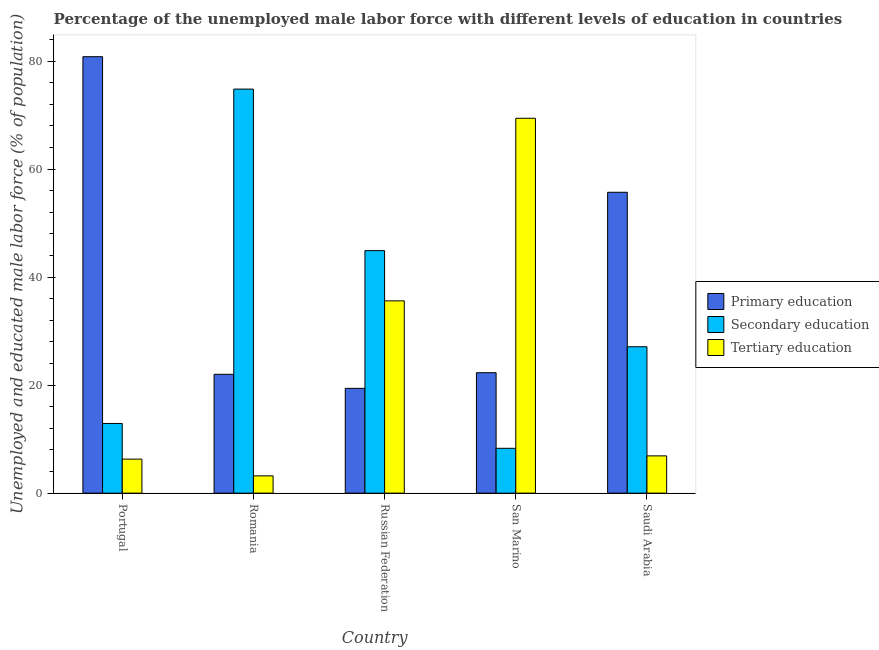How many different coloured bars are there?
Make the answer very short. 3. How many bars are there on the 1st tick from the left?
Give a very brief answer. 3. What is the label of the 5th group of bars from the left?
Your response must be concise. Saudi Arabia. What is the percentage of male labor force who received tertiary education in Portugal?
Provide a short and direct response. 6.3. Across all countries, what is the maximum percentage of male labor force who received tertiary education?
Your answer should be very brief. 69.4. Across all countries, what is the minimum percentage of male labor force who received secondary education?
Make the answer very short. 8.3. In which country was the percentage of male labor force who received primary education minimum?
Offer a terse response. Russian Federation. What is the total percentage of male labor force who received primary education in the graph?
Provide a succinct answer. 200.2. What is the difference between the percentage of male labor force who received tertiary education in Russian Federation and that in San Marino?
Give a very brief answer. -33.8. What is the difference between the percentage of male labor force who received tertiary education in Russian Federation and the percentage of male labor force who received primary education in San Marino?
Provide a short and direct response. 13.3. What is the average percentage of male labor force who received tertiary education per country?
Offer a very short reply. 24.28. What is the difference between the percentage of male labor force who received tertiary education and percentage of male labor force who received primary education in Portugal?
Provide a short and direct response. -74.5. In how many countries, is the percentage of male labor force who received tertiary education greater than 8 %?
Offer a terse response. 2. What is the ratio of the percentage of male labor force who received tertiary education in Russian Federation to that in San Marino?
Provide a succinct answer. 0.51. What is the difference between the highest and the second highest percentage of male labor force who received tertiary education?
Your answer should be very brief. 33.8. What is the difference between the highest and the lowest percentage of male labor force who received primary education?
Keep it short and to the point. 61.4. Is the sum of the percentage of male labor force who received tertiary education in Portugal and Saudi Arabia greater than the maximum percentage of male labor force who received secondary education across all countries?
Your answer should be compact. No. What does the 2nd bar from the left in Portugal represents?
Ensure brevity in your answer.  Secondary education. What does the 1st bar from the right in Russian Federation represents?
Ensure brevity in your answer.  Tertiary education. How many bars are there?
Your response must be concise. 15. How are the legend labels stacked?
Provide a short and direct response. Vertical. What is the title of the graph?
Provide a succinct answer. Percentage of the unemployed male labor force with different levels of education in countries. What is the label or title of the Y-axis?
Offer a very short reply. Unemployed and educated male labor force (% of population). What is the Unemployed and educated male labor force (% of population) of Primary education in Portugal?
Ensure brevity in your answer.  80.8. What is the Unemployed and educated male labor force (% of population) in Secondary education in Portugal?
Your response must be concise. 12.9. What is the Unemployed and educated male labor force (% of population) of Tertiary education in Portugal?
Ensure brevity in your answer.  6.3. What is the Unemployed and educated male labor force (% of population) of Secondary education in Romania?
Provide a succinct answer. 74.8. What is the Unemployed and educated male labor force (% of population) in Tertiary education in Romania?
Your answer should be compact. 3.2. What is the Unemployed and educated male labor force (% of population) in Primary education in Russian Federation?
Make the answer very short. 19.4. What is the Unemployed and educated male labor force (% of population) of Secondary education in Russian Federation?
Keep it short and to the point. 44.9. What is the Unemployed and educated male labor force (% of population) of Tertiary education in Russian Federation?
Ensure brevity in your answer.  35.6. What is the Unemployed and educated male labor force (% of population) in Primary education in San Marino?
Your answer should be very brief. 22.3. What is the Unemployed and educated male labor force (% of population) of Secondary education in San Marino?
Provide a succinct answer. 8.3. What is the Unemployed and educated male labor force (% of population) in Tertiary education in San Marino?
Give a very brief answer. 69.4. What is the Unemployed and educated male labor force (% of population) in Primary education in Saudi Arabia?
Your answer should be compact. 55.7. What is the Unemployed and educated male labor force (% of population) in Secondary education in Saudi Arabia?
Your answer should be compact. 27.1. What is the Unemployed and educated male labor force (% of population) of Tertiary education in Saudi Arabia?
Make the answer very short. 6.9. Across all countries, what is the maximum Unemployed and educated male labor force (% of population) in Primary education?
Your answer should be very brief. 80.8. Across all countries, what is the maximum Unemployed and educated male labor force (% of population) in Secondary education?
Provide a short and direct response. 74.8. Across all countries, what is the maximum Unemployed and educated male labor force (% of population) of Tertiary education?
Your answer should be compact. 69.4. Across all countries, what is the minimum Unemployed and educated male labor force (% of population) of Primary education?
Make the answer very short. 19.4. Across all countries, what is the minimum Unemployed and educated male labor force (% of population) of Secondary education?
Your answer should be compact. 8.3. Across all countries, what is the minimum Unemployed and educated male labor force (% of population) of Tertiary education?
Provide a short and direct response. 3.2. What is the total Unemployed and educated male labor force (% of population) of Primary education in the graph?
Keep it short and to the point. 200.2. What is the total Unemployed and educated male labor force (% of population) of Secondary education in the graph?
Keep it short and to the point. 168. What is the total Unemployed and educated male labor force (% of population) of Tertiary education in the graph?
Provide a succinct answer. 121.4. What is the difference between the Unemployed and educated male labor force (% of population) of Primary education in Portugal and that in Romania?
Your response must be concise. 58.8. What is the difference between the Unemployed and educated male labor force (% of population) of Secondary education in Portugal and that in Romania?
Provide a short and direct response. -61.9. What is the difference between the Unemployed and educated male labor force (% of population) in Tertiary education in Portugal and that in Romania?
Provide a succinct answer. 3.1. What is the difference between the Unemployed and educated male labor force (% of population) in Primary education in Portugal and that in Russian Federation?
Your answer should be very brief. 61.4. What is the difference between the Unemployed and educated male labor force (% of population) in Secondary education in Portugal and that in Russian Federation?
Provide a succinct answer. -32. What is the difference between the Unemployed and educated male labor force (% of population) of Tertiary education in Portugal and that in Russian Federation?
Your answer should be very brief. -29.3. What is the difference between the Unemployed and educated male labor force (% of population) of Primary education in Portugal and that in San Marino?
Your response must be concise. 58.5. What is the difference between the Unemployed and educated male labor force (% of population) of Secondary education in Portugal and that in San Marino?
Keep it short and to the point. 4.6. What is the difference between the Unemployed and educated male labor force (% of population) of Tertiary education in Portugal and that in San Marino?
Offer a terse response. -63.1. What is the difference between the Unemployed and educated male labor force (% of population) of Primary education in Portugal and that in Saudi Arabia?
Your answer should be very brief. 25.1. What is the difference between the Unemployed and educated male labor force (% of population) of Secondary education in Portugal and that in Saudi Arabia?
Provide a short and direct response. -14.2. What is the difference between the Unemployed and educated male labor force (% of population) in Tertiary education in Portugal and that in Saudi Arabia?
Give a very brief answer. -0.6. What is the difference between the Unemployed and educated male labor force (% of population) of Primary education in Romania and that in Russian Federation?
Make the answer very short. 2.6. What is the difference between the Unemployed and educated male labor force (% of population) of Secondary education in Romania and that in Russian Federation?
Your response must be concise. 29.9. What is the difference between the Unemployed and educated male labor force (% of population) of Tertiary education in Romania and that in Russian Federation?
Ensure brevity in your answer.  -32.4. What is the difference between the Unemployed and educated male labor force (% of population) in Secondary education in Romania and that in San Marino?
Your answer should be very brief. 66.5. What is the difference between the Unemployed and educated male labor force (% of population) in Tertiary education in Romania and that in San Marino?
Offer a terse response. -66.2. What is the difference between the Unemployed and educated male labor force (% of population) in Primary education in Romania and that in Saudi Arabia?
Keep it short and to the point. -33.7. What is the difference between the Unemployed and educated male labor force (% of population) in Secondary education in Romania and that in Saudi Arabia?
Your answer should be compact. 47.7. What is the difference between the Unemployed and educated male labor force (% of population) of Secondary education in Russian Federation and that in San Marino?
Give a very brief answer. 36.6. What is the difference between the Unemployed and educated male labor force (% of population) in Tertiary education in Russian Federation and that in San Marino?
Offer a terse response. -33.8. What is the difference between the Unemployed and educated male labor force (% of population) in Primary education in Russian Federation and that in Saudi Arabia?
Provide a succinct answer. -36.3. What is the difference between the Unemployed and educated male labor force (% of population) in Tertiary education in Russian Federation and that in Saudi Arabia?
Offer a terse response. 28.7. What is the difference between the Unemployed and educated male labor force (% of population) in Primary education in San Marino and that in Saudi Arabia?
Offer a very short reply. -33.4. What is the difference between the Unemployed and educated male labor force (% of population) in Secondary education in San Marino and that in Saudi Arabia?
Provide a short and direct response. -18.8. What is the difference between the Unemployed and educated male labor force (% of population) of Tertiary education in San Marino and that in Saudi Arabia?
Ensure brevity in your answer.  62.5. What is the difference between the Unemployed and educated male labor force (% of population) in Primary education in Portugal and the Unemployed and educated male labor force (% of population) in Secondary education in Romania?
Keep it short and to the point. 6. What is the difference between the Unemployed and educated male labor force (% of population) of Primary education in Portugal and the Unemployed and educated male labor force (% of population) of Tertiary education in Romania?
Make the answer very short. 77.6. What is the difference between the Unemployed and educated male labor force (% of population) of Secondary education in Portugal and the Unemployed and educated male labor force (% of population) of Tertiary education in Romania?
Give a very brief answer. 9.7. What is the difference between the Unemployed and educated male labor force (% of population) in Primary education in Portugal and the Unemployed and educated male labor force (% of population) in Secondary education in Russian Federation?
Make the answer very short. 35.9. What is the difference between the Unemployed and educated male labor force (% of population) of Primary education in Portugal and the Unemployed and educated male labor force (% of population) of Tertiary education in Russian Federation?
Provide a short and direct response. 45.2. What is the difference between the Unemployed and educated male labor force (% of population) in Secondary education in Portugal and the Unemployed and educated male labor force (% of population) in Tertiary education in Russian Federation?
Ensure brevity in your answer.  -22.7. What is the difference between the Unemployed and educated male labor force (% of population) in Primary education in Portugal and the Unemployed and educated male labor force (% of population) in Secondary education in San Marino?
Offer a very short reply. 72.5. What is the difference between the Unemployed and educated male labor force (% of population) in Secondary education in Portugal and the Unemployed and educated male labor force (% of population) in Tertiary education in San Marino?
Your answer should be compact. -56.5. What is the difference between the Unemployed and educated male labor force (% of population) of Primary education in Portugal and the Unemployed and educated male labor force (% of population) of Secondary education in Saudi Arabia?
Your answer should be compact. 53.7. What is the difference between the Unemployed and educated male labor force (% of population) of Primary education in Portugal and the Unemployed and educated male labor force (% of population) of Tertiary education in Saudi Arabia?
Ensure brevity in your answer.  73.9. What is the difference between the Unemployed and educated male labor force (% of population) in Secondary education in Portugal and the Unemployed and educated male labor force (% of population) in Tertiary education in Saudi Arabia?
Give a very brief answer. 6. What is the difference between the Unemployed and educated male labor force (% of population) in Primary education in Romania and the Unemployed and educated male labor force (% of population) in Secondary education in Russian Federation?
Provide a short and direct response. -22.9. What is the difference between the Unemployed and educated male labor force (% of population) of Primary education in Romania and the Unemployed and educated male labor force (% of population) of Tertiary education in Russian Federation?
Your response must be concise. -13.6. What is the difference between the Unemployed and educated male labor force (% of population) in Secondary education in Romania and the Unemployed and educated male labor force (% of population) in Tertiary education in Russian Federation?
Your answer should be compact. 39.2. What is the difference between the Unemployed and educated male labor force (% of population) of Primary education in Romania and the Unemployed and educated male labor force (% of population) of Tertiary education in San Marino?
Offer a terse response. -47.4. What is the difference between the Unemployed and educated male labor force (% of population) of Secondary education in Romania and the Unemployed and educated male labor force (% of population) of Tertiary education in San Marino?
Your answer should be compact. 5.4. What is the difference between the Unemployed and educated male labor force (% of population) of Secondary education in Romania and the Unemployed and educated male labor force (% of population) of Tertiary education in Saudi Arabia?
Offer a terse response. 67.9. What is the difference between the Unemployed and educated male labor force (% of population) of Primary education in Russian Federation and the Unemployed and educated male labor force (% of population) of Secondary education in San Marino?
Offer a very short reply. 11.1. What is the difference between the Unemployed and educated male labor force (% of population) in Primary education in Russian Federation and the Unemployed and educated male labor force (% of population) in Tertiary education in San Marino?
Keep it short and to the point. -50. What is the difference between the Unemployed and educated male labor force (% of population) of Secondary education in Russian Federation and the Unemployed and educated male labor force (% of population) of Tertiary education in San Marino?
Offer a very short reply. -24.5. What is the difference between the Unemployed and educated male labor force (% of population) in Primary education in San Marino and the Unemployed and educated male labor force (% of population) in Tertiary education in Saudi Arabia?
Provide a succinct answer. 15.4. What is the difference between the Unemployed and educated male labor force (% of population) of Secondary education in San Marino and the Unemployed and educated male labor force (% of population) of Tertiary education in Saudi Arabia?
Your answer should be very brief. 1.4. What is the average Unemployed and educated male labor force (% of population) of Primary education per country?
Ensure brevity in your answer.  40.04. What is the average Unemployed and educated male labor force (% of population) in Secondary education per country?
Your answer should be compact. 33.6. What is the average Unemployed and educated male labor force (% of population) in Tertiary education per country?
Provide a short and direct response. 24.28. What is the difference between the Unemployed and educated male labor force (% of population) in Primary education and Unemployed and educated male labor force (% of population) in Secondary education in Portugal?
Your response must be concise. 67.9. What is the difference between the Unemployed and educated male labor force (% of population) of Primary education and Unemployed and educated male labor force (% of population) of Tertiary education in Portugal?
Offer a terse response. 74.5. What is the difference between the Unemployed and educated male labor force (% of population) of Primary education and Unemployed and educated male labor force (% of population) of Secondary education in Romania?
Your response must be concise. -52.8. What is the difference between the Unemployed and educated male labor force (% of population) in Secondary education and Unemployed and educated male labor force (% of population) in Tertiary education in Romania?
Ensure brevity in your answer.  71.6. What is the difference between the Unemployed and educated male labor force (% of population) in Primary education and Unemployed and educated male labor force (% of population) in Secondary education in Russian Federation?
Keep it short and to the point. -25.5. What is the difference between the Unemployed and educated male labor force (% of population) in Primary education and Unemployed and educated male labor force (% of population) in Tertiary education in Russian Federation?
Keep it short and to the point. -16.2. What is the difference between the Unemployed and educated male labor force (% of population) in Secondary education and Unemployed and educated male labor force (% of population) in Tertiary education in Russian Federation?
Your response must be concise. 9.3. What is the difference between the Unemployed and educated male labor force (% of population) of Primary education and Unemployed and educated male labor force (% of population) of Secondary education in San Marino?
Keep it short and to the point. 14. What is the difference between the Unemployed and educated male labor force (% of population) of Primary education and Unemployed and educated male labor force (% of population) of Tertiary education in San Marino?
Provide a succinct answer. -47.1. What is the difference between the Unemployed and educated male labor force (% of population) in Secondary education and Unemployed and educated male labor force (% of population) in Tertiary education in San Marino?
Offer a very short reply. -61.1. What is the difference between the Unemployed and educated male labor force (% of population) in Primary education and Unemployed and educated male labor force (% of population) in Secondary education in Saudi Arabia?
Offer a terse response. 28.6. What is the difference between the Unemployed and educated male labor force (% of population) in Primary education and Unemployed and educated male labor force (% of population) in Tertiary education in Saudi Arabia?
Provide a short and direct response. 48.8. What is the difference between the Unemployed and educated male labor force (% of population) in Secondary education and Unemployed and educated male labor force (% of population) in Tertiary education in Saudi Arabia?
Ensure brevity in your answer.  20.2. What is the ratio of the Unemployed and educated male labor force (% of population) in Primary education in Portugal to that in Romania?
Keep it short and to the point. 3.67. What is the ratio of the Unemployed and educated male labor force (% of population) of Secondary education in Portugal to that in Romania?
Provide a succinct answer. 0.17. What is the ratio of the Unemployed and educated male labor force (% of population) in Tertiary education in Portugal to that in Romania?
Make the answer very short. 1.97. What is the ratio of the Unemployed and educated male labor force (% of population) in Primary education in Portugal to that in Russian Federation?
Ensure brevity in your answer.  4.16. What is the ratio of the Unemployed and educated male labor force (% of population) in Secondary education in Portugal to that in Russian Federation?
Ensure brevity in your answer.  0.29. What is the ratio of the Unemployed and educated male labor force (% of population) of Tertiary education in Portugal to that in Russian Federation?
Your response must be concise. 0.18. What is the ratio of the Unemployed and educated male labor force (% of population) in Primary education in Portugal to that in San Marino?
Offer a very short reply. 3.62. What is the ratio of the Unemployed and educated male labor force (% of population) of Secondary education in Portugal to that in San Marino?
Ensure brevity in your answer.  1.55. What is the ratio of the Unemployed and educated male labor force (% of population) in Tertiary education in Portugal to that in San Marino?
Offer a terse response. 0.09. What is the ratio of the Unemployed and educated male labor force (% of population) in Primary education in Portugal to that in Saudi Arabia?
Your answer should be very brief. 1.45. What is the ratio of the Unemployed and educated male labor force (% of population) of Secondary education in Portugal to that in Saudi Arabia?
Keep it short and to the point. 0.48. What is the ratio of the Unemployed and educated male labor force (% of population) in Tertiary education in Portugal to that in Saudi Arabia?
Your answer should be very brief. 0.91. What is the ratio of the Unemployed and educated male labor force (% of population) in Primary education in Romania to that in Russian Federation?
Provide a succinct answer. 1.13. What is the ratio of the Unemployed and educated male labor force (% of population) in Secondary education in Romania to that in Russian Federation?
Ensure brevity in your answer.  1.67. What is the ratio of the Unemployed and educated male labor force (% of population) in Tertiary education in Romania to that in Russian Federation?
Provide a succinct answer. 0.09. What is the ratio of the Unemployed and educated male labor force (% of population) of Primary education in Romania to that in San Marino?
Ensure brevity in your answer.  0.99. What is the ratio of the Unemployed and educated male labor force (% of population) of Secondary education in Romania to that in San Marino?
Your answer should be compact. 9.01. What is the ratio of the Unemployed and educated male labor force (% of population) of Tertiary education in Romania to that in San Marino?
Provide a succinct answer. 0.05. What is the ratio of the Unemployed and educated male labor force (% of population) of Primary education in Romania to that in Saudi Arabia?
Your answer should be very brief. 0.4. What is the ratio of the Unemployed and educated male labor force (% of population) of Secondary education in Romania to that in Saudi Arabia?
Provide a short and direct response. 2.76. What is the ratio of the Unemployed and educated male labor force (% of population) of Tertiary education in Romania to that in Saudi Arabia?
Provide a short and direct response. 0.46. What is the ratio of the Unemployed and educated male labor force (% of population) in Primary education in Russian Federation to that in San Marino?
Keep it short and to the point. 0.87. What is the ratio of the Unemployed and educated male labor force (% of population) of Secondary education in Russian Federation to that in San Marino?
Give a very brief answer. 5.41. What is the ratio of the Unemployed and educated male labor force (% of population) in Tertiary education in Russian Federation to that in San Marino?
Your answer should be very brief. 0.51. What is the ratio of the Unemployed and educated male labor force (% of population) in Primary education in Russian Federation to that in Saudi Arabia?
Provide a short and direct response. 0.35. What is the ratio of the Unemployed and educated male labor force (% of population) in Secondary education in Russian Federation to that in Saudi Arabia?
Provide a succinct answer. 1.66. What is the ratio of the Unemployed and educated male labor force (% of population) of Tertiary education in Russian Federation to that in Saudi Arabia?
Provide a succinct answer. 5.16. What is the ratio of the Unemployed and educated male labor force (% of population) of Primary education in San Marino to that in Saudi Arabia?
Give a very brief answer. 0.4. What is the ratio of the Unemployed and educated male labor force (% of population) in Secondary education in San Marino to that in Saudi Arabia?
Your answer should be compact. 0.31. What is the ratio of the Unemployed and educated male labor force (% of population) in Tertiary education in San Marino to that in Saudi Arabia?
Make the answer very short. 10.06. What is the difference between the highest and the second highest Unemployed and educated male labor force (% of population) in Primary education?
Ensure brevity in your answer.  25.1. What is the difference between the highest and the second highest Unemployed and educated male labor force (% of population) in Secondary education?
Your response must be concise. 29.9. What is the difference between the highest and the second highest Unemployed and educated male labor force (% of population) in Tertiary education?
Provide a succinct answer. 33.8. What is the difference between the highest and the lowest Unemployed and educated male labor force (% of population) in Primary education?
Keep it short and to the point. 61.4. What is the difference between the highest and the lowest Unemployed and educated male labor force (% of population) of Secondary education?
Provide a succinct answer. 66.5. What is the difference between the highest and the lowest Unemployed and educated male labor force (% of population) in Tertiary education?
Ensure brevity in your answer.  66.2. 